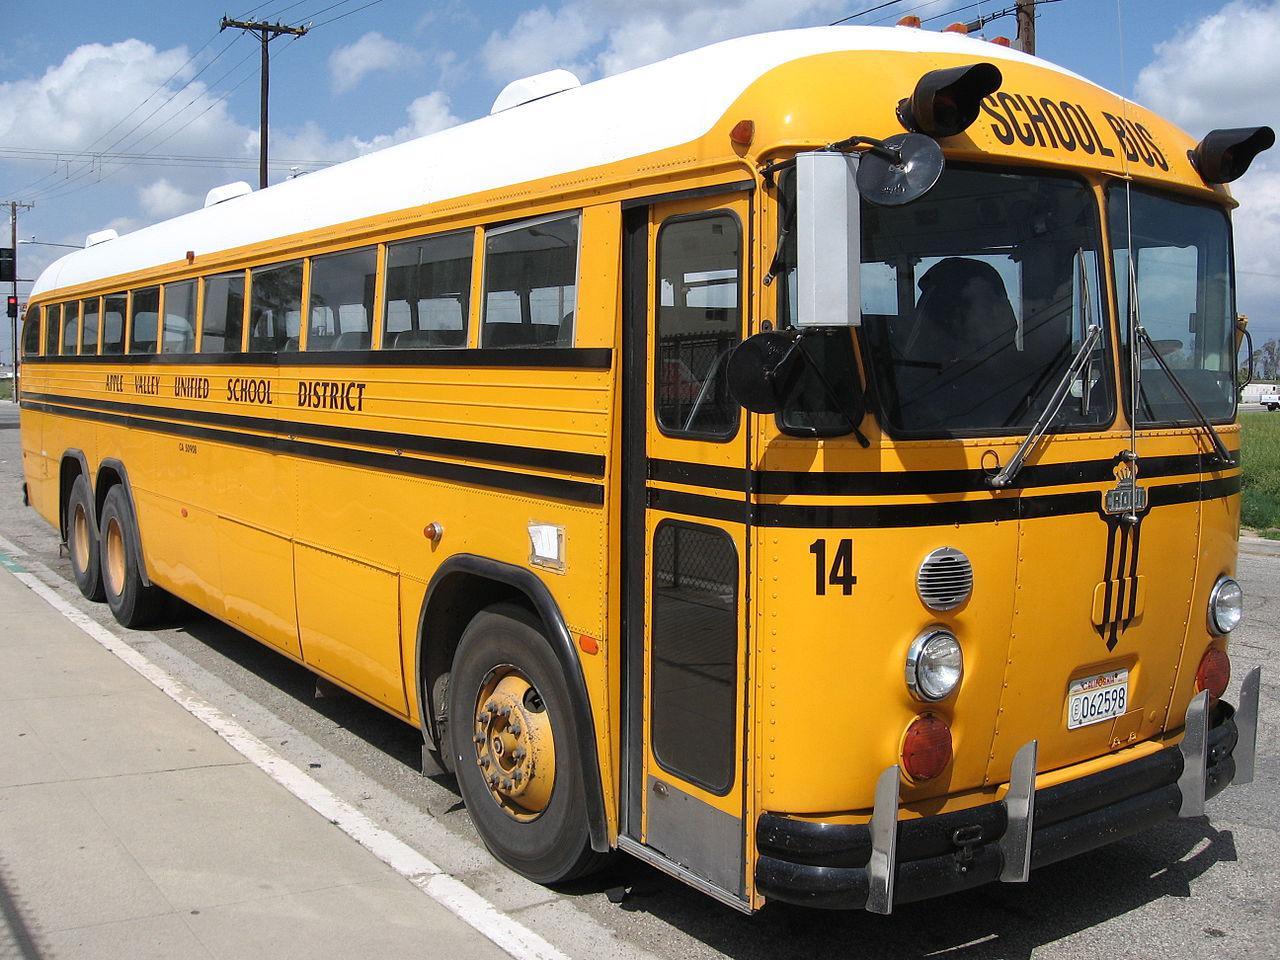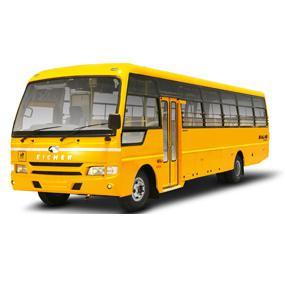The first image is the image on the left, the second image is the image on the right. Analyze the images presented: Is the assertion "Each image shows a single yellow bus with a nearly flat front, and the bus on the right is displayed at an angle but does not have a black stripe visible on its side." valid? Answer yes or no. Yes. The first image is the image on the left, the second image is the image on the right. Given the left and right images, does the statement "there is a yellow school bus with a flat front and the stop sign visible" hold true? Answer yes or no. No. 